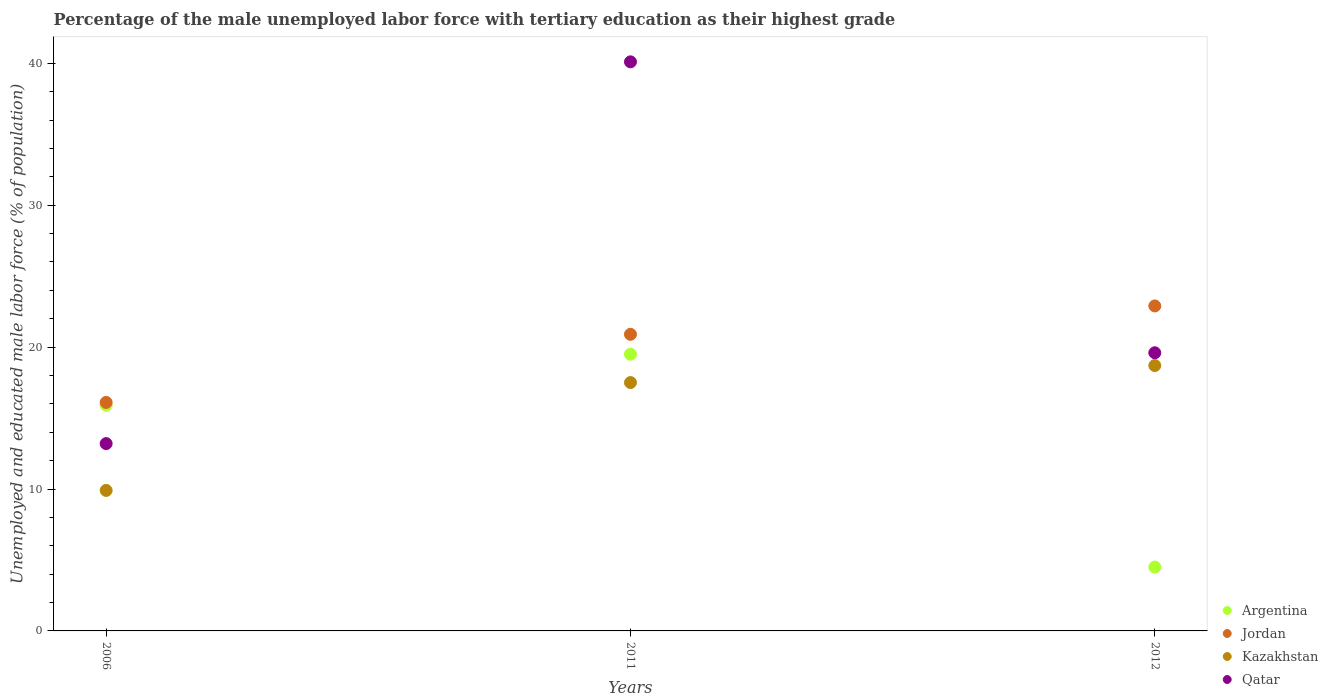How many different coloured dotlines are there?
Your answer should be compact. 4. Is the number of dotlines equal to the number of legend labels?
Your answer should be compact. Yes. What is the percentage of the unemployed male labor force with tertiary education in Jordan in 2006?
Your answer should be very brief. 16.1. Across all years, what is the maximum percentage of the unemployed male labor force with tertiary education in Jordan?
Your answer should be compact. 22.9. Across all years, what is the minimum percentage of the unemployed male labor force with tertiary education in Qatar?
Offer a terse response. 13.2. What is the total percentage of the unemployed male labor force with tertiary education in Kazakhstan in the graph?
Give a very brief answer. 46.1. What is the difference between the percentage of the unemployed male labor force with tertiary education in Argentina in 2011 and that in 2012?
Offer a very short reply. 15. What is the difference between the percentage of the unemployed male labor force with tertiary education in Argentina in 2011 and the percentage of the unemployed male labor force with tertiary education in Qatar in 2012?
Make the answer very short. -0.1. What is the average percentage of the unemployed male labor force with tertiary education in Argentina per year?
Keep it short and to the point. 13.3. What is the ratio of the percentage of the unemployed male labor force with tertiary education in Jordan in 2011 to that in 2012?
Your response must be concise. 0.91. Is the percentage of the unemployed male labor force with tertiary education in Argentina in 2011 less than that in 2012?
Provide a succinct answer. No. Is the difference between the percentage of the unemployed male labor force with tertiary education in Kazakhstan in 2011 and 2012 greater than the difference between the percentage of the unemployed male labor force with tertiary education in Argentina in 2011 and 2012?
Offer a terse response. No. What is the difference between the highest and the second highest percentage of the unemployed male labor force with tertiary education in Argentina?
Offer a very short reply. 3.6. What is the difference between the highest and the lowest percentage of the unemployed male labor force with tertiary education in Qatar?
Your response must be concise. 26.9. Is the sum of the percentage of the unemployed male labor force with tertiary education in Argentina in 2011 and 2012 greater than the maximum percentage of the unemployed male labor force with tertiary education in Qatar across all years?
Give a very brief answer. No. Is it the case that in every year, the sum of the percentage of the unemployed male labor force with tertiary education in Jordan and percentage of the unemployed male labor force with tertiary education in Qatar  is greater than the percentage of the unemployed male labor force with tertiary education in Kazakhstan?
Provide a succinct answer. Yes. How many dotlines are there?
Your answer should be very brief. 4. How many years are there in the graph?
Offer a very short reply. 3. Are the values on the major ticks of Y-axis written in scientific E-notation?
Offer a very short reply. No. What is the title of the graph?
Keep it short and to the point. Percentage of the male unemployed labor force with tertiary education as their highest grade. What is the label or title of the Y-axis?
Your answer should be compact. Unemployed and educated male labor force (% of population). What is the Unemployed and educated male labor force (% of population) in Argentina in 2006?
Your response must be concise. 15.9. What is the Unemployed and educated male labor force (% of population) in Jordan in 2006?
Make the answer very short. 16.1. What is the Unemployed and educated male labor force (% of population) in Kazakhstan in 2006?
Keep it short and to the point. 9.9. What is the Unemployed and educated male labor force (% of population) of Qatar in 2006?
Provide a succinct answer. 13.2. What is the Unemployed and educated male labor force (% of population) of Argentina in 2011?
Your response must be concise. 19.5. What is the Unemployed and educated male labor force (% of population) in Jordan in 2011?
Make the answer very short. 20.9. What is the Unemployed and educated male labor force (% of population) of Qatar in 2011?
Provide a short and direct response. 40.1. What is the Unemployed and educated male labor force (% of population) in Argentina in 2012?
Give a very brief answer. 4.5. What is the Unemployed and educated male labor force (% of population) of Jordan in 2012?
Provide a succinct answer. 22.9. What is the Unemployed and educated male labor force (% of population) in Kazakhstan in 2012?
Offer a very short reply. 18.7. What is the Unemployed and educated male labor force (% of population) in Qatar in 2012?
Offer a very short reply. 19.6. Across all years, what is the maximum Unemployed and educated male labor force (% of population) in Jordan?
Provide a succinct answer. 22.9. Across all years, what is the maximum Unemployed and educated male labor force (% of population) in Kazakhstan?
Your response must be concise. 18.7. Across all years, what is the maximum Unemployed and educated male labor force (% of population) of Qatar?
Provide a succinct answer. 40.1. Across all years, what is the minimum Unemployed and educated male labor force (% of population) of Jordan?
Give a very brief answer. 16.1. Across all years, what is the minimum Unemployed and educated male labor force (% of population) of Kazakhstan?
Your answer should be very brief. 9.9. Across all years, what is the minimum Unemployed and educated male labor force (% of population) in Qatar?
Ensure brevity in your answer.  13.2. What is the total Unemployed and educated male labor force (% of population) of Argentina in the graph?
Keep it short and to the point. 39.9. What is the total Unemployed and educated male labor force (% of population) in Jordan in the graph?
Give a very brief answer. 59.9. What is the total Unemployed and educated male labor force (% of population) of Kazakhstan in the graph?
Your answer should be compact. 46.1. What is the total Unemployed and educated male labor force (% of population) in Qatar in the graph?
Ensure brevity in your answer.  72.9. What is the difference between the Unemployed and educated male labor force (% of population) of Jordan in 2006 and that in 2011?
Provide a short and direct response. -4.8. What is the difference between the Unemployed and educated male labor force (% of population) of Kazakhstan in 2006 and that in 2011?
Your answer should be very brief. -7.6. What is the difference between the Unemployed and educated male labor force (% of population) of Qatar in 2006 and that in 2011?
Give a very brief answer. -26.9. What is the difference between the Unemployed and educated male labor force (% of population) of Jordan in 2006 and that in 2012?
Give a very brief answer. -6.8. What is the difference between the Unemployed and educated male labor force (% of population) of Kazakhstan in 2006 and that in 2012?
Offer a very short reply. -8.8. What is the difference between the Unemployed and educated male labor force (% of population) of Argentina in 2011 and that in 2012?
Provide a succinct answer. 15. What is the difference between the Unemployed and educated male labor force (% of population) of Jordan in 2011 and that in 2012?
Give a very brief answer. -2. What is the difference between the Unemployed and educated male labor force (% of population) of Argentina in 2006 and the Unemployed and educated male labor force (% of population) of Qatar in 2011?
Keep it short and to the point. -24.2. What is the difference between the Unemployed and educated male labor force (% of population) of Kazakhstan in 2006 and the Unemployed and educated male labor force (% of population) of Qatar in 2011?
Ensure brevity in your answer.  -30.2. What is the difference between the Unemployed and educated male labor force (% of population) of Argentina in 2011 and the Unemployed and educated male labor force (% of population) of Qatar in 2012?
Your answer should be very brief. -0.1. What is the difference between the Unemployed and educated male labor force (% of population) in Jordan in 2011 and the Unemployed and educated male labor force (% of population) in Kazakhstan in 2012?
Your response must be concise. 2.2. What is the difference between the Unemployed and educated male labor force (% of population) of Kazakhstan in 2011 and the Unemployed and educated male labor force (% of population) of Qatar in 2012?
Make the answer very short. -2.1. What is the average Unemployed and educated male labor force (% of population) in Jordan per year?
Ensure brevity in your answer.  19.97. What is the average Unemployed and educated male labor force (% of population) of Kazakhstan per year?
Offer a terse response. 15.37. What is the average Unemployed and educated male labor force (% of population) in Qatar per year?
Your answer should be compact. 24.3. In the year 2006, what is the difference between the Unemployed and educated male labor force (% of population) in Argentina and Unemployed and educated male labor force (% of population) in Jordan?
Provide a short and direct response. -0.2. In the year 2006, what is the difference between the Unemployed and educated male labor force (% of population) of Argentina and Unemployed and educated male labor force (% of population) of Kazakhstan?
Ensure brevity in your answer.  6. In the year 2006, what is the difference between the Unemployed and educated male labor force (% of population) of Argentina and Unemployed and educated male labor force (% of population) of Qatar?
Offer a very short reply. 2.7. In the year 2006, what is the difference between the Unemployed and educated male labor force (% of population) in Jordan and Unemployed and educated male labor force (% of population) in Kazakhstan?
Provide a succinct answer. 6.2. In the year 2006, what is the difference between the Unemployed and educated male labor force (% of population) in Jordan and Unemployed and educated male labor force (% of population) in Qatar?
Provide a short and direct response. 2.9. In the year 2006, what is the difference between the Unemployed and educated male labor force (% of population) of Kazakhstan and Unemployed and educated male labor force (% of population) of Qatar?
Offer a terse response. -3.3. In the year 2011, what is the difference between the Unemployed and educated male labor force (% of population) in Argentina and Unemployed and educated male labor force (% of population) in Jordan?
Offer a terse response. -1.4. In the year 2011, what is the difference between the Unemployed and educated male labor force (% of population) in Argentina and Unemployed and educated male labor force (% of population) in Kazakhstan?
Your answer should be compact. 2. In the year 2011, what is the difference between the Unemployed and educated male labor force (% of population) of Argentina and Unemployed and educated male labor force (% of population) of Qatar?
Make the answer very short. -20.6. In the year 2011, what is the difference between the Unemployed and educated male labor force (% of population) in Jordan and Unemployed and educated male labor force (% of population) in Kazakhstan?
Give a very brief answer. 3.4. In the year 2011, what is the difference between the Unemployed and educated male labor force (% of population) of Jordan and Unemployed and educated male labor force (% of population) of Qatar?
Give a very brief answer. -19.2. In the year 2011, what is the difference between the Unemployed and educated male labor force (% of population) of Kazakhstan and Unemployed and educated male labor force (% of population) of Qatar?
Give a very brief answer. -22.6. In the year 2012, what is the difference between the Unemployed and educated male labor force (% of population) of Argentina and Unemployed and educated male labor force (% of population) of Jordan?
Offer a terse response. -18.4. In the year 2012, what is the difference between the Unemployed and educated male labor force (% of population) of Argentina and Unemployed and educated male labor force (% of population) of Kazakhstan?
Provide a succinct answer. -14.2. In the year 2012, what is the difference between the Unemployed and educated male labor force (% of population) of Argentina and Unemployed and educated male labor force (% of population) of Qatar?
Your answer should be compact. -15.1. In the year 2012, what is the difference between the Unemployed and educated male labor force (% of population) in Jordan and Unemployed and educated male labor force (% of population) in Kazakhstan?
Offer a very short reply. 4.2. In the year 2012, what is the difference between the Unemployed and educated male labor force (% of population) in Kazakhstan and Unemployed and educated male labor force (% of population) in Qatar?
Make the answer very short. -0.9. What is the ratio of the Unemployed and educated male labor force (% of population) of Argentina in 2006 to that in 2011?
Provide a succinct answer. 0.82. What is the ratio of the Unemployed and educated male labor force (% of population) in Jordan in 2006 to that in 2011?
Keep it short and to the point. 0.77. What is the ratio of the Unemployed and educated male labor force (% of population) in Kazakhstan in 2006 to that in 2011?
Your answer should be very brief. 0.57. What is the ratio of the Unemployed and educated male labor force (% of population) of Qatar in 2006 to that in 2011?
Provide a succinct answer. 0.33. What is the ratio of the Unemployed and educated male labor force (% of population) in Argentina in 2006 to that in 2012?
Offer a terse response. 3.53. What is the ratio of the Unemployed and educated male labor force (% of population) in Jordan in 2006 to that in 2012?
Your response must be concise. 0.7. What is the ratio of the Unemployed and educated male labor force (% of population) of Kazakhstan in 2006 to that in 2012?
Give a very brief answer. 0.53. What is the ratio of the Unemployed and educated male labor force (% of population) of Qatar in 2006 to that in 2012?
Your answer should be compact. 0.67. What is the ratio of the Unemployed and educated male labor force (% of population) in Argentina in 2011 to that in 2012?
Your answer should be compact. 4.33. What is the ratio of the Unemployed and educated male labor force (% of population) of Jordan in 2011 to that in 2012?
Give a very brief answer. 0.91. What is the ratio of the Unemployed and educated male labor force (% of population) in Kazakhstan in 2011 to that in 2012?
Your response must be concise. 0.94. What is the ratio of the Unemployed and educated male labor force (% of population) of Qatar in 2011 to that in 2012?
Offer a very short reply. 2.05. What is the difference between the highest and the second highest Unemployed and educated male labor force (% of population) in Jordan?
Give a very brief answer. 2. What is the difference between the highest and the second highest Unemployed and educated male labor force (% of population) of Kazakhstan?
Keep it short and to the point. 1.2. What is the difference between the highest and the second highest Unemployed and educated male labor force (% of population) in Qatar?
Offer a terse response. 20.5. What is the difference between the highest and the lowest Unemployed and educated male labor force (% of population) of Argentina?
Make the answer very short. 15. What is the difference between the highest and the lowest Unemployed and educated male labor force (% of population) in Kazakhstan?
Your response must be concise. 8.8. What is the difference between the highest and the lowest Unemployed and educated male labor force (% of population) of Qatar?
Your answer should be compact. 26.9. 